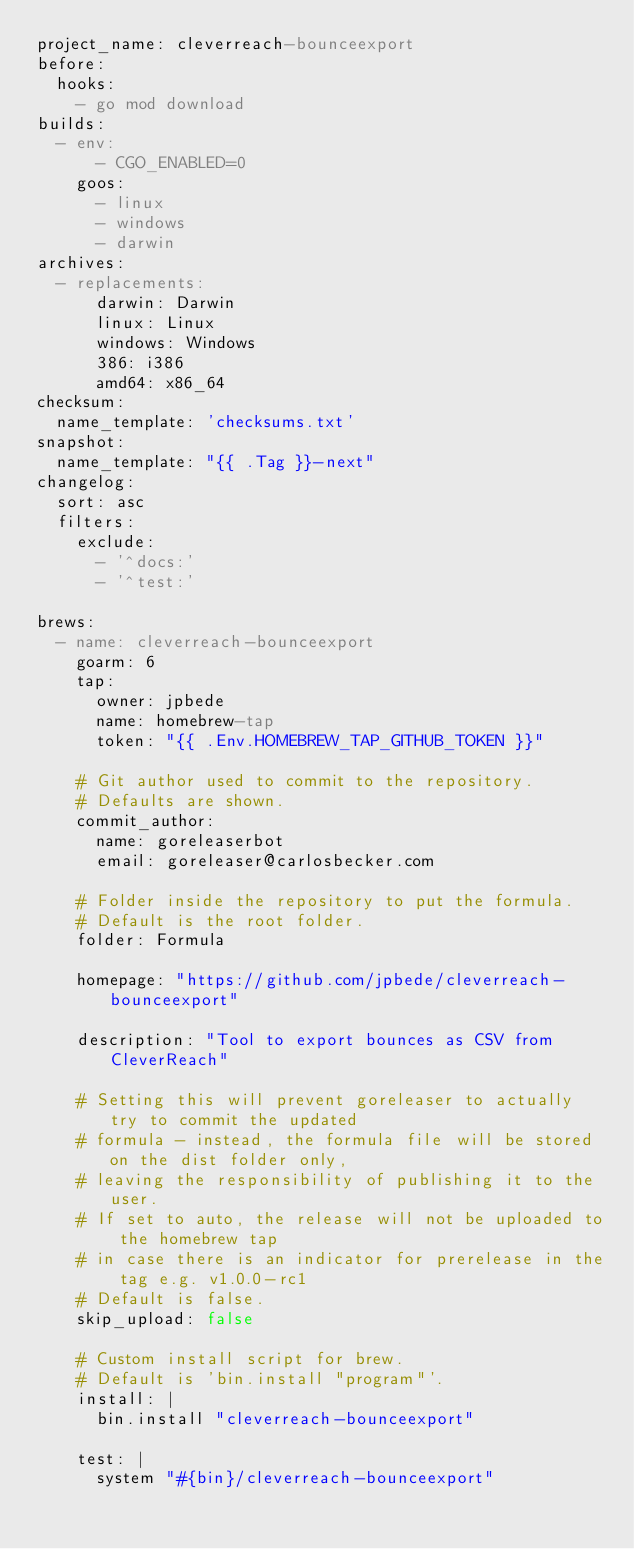Convert code to text. <code><loc_0><loc_0><loc_500><loc_500><_YAML_>project_name: cleverreach-bounceexport
before:
  hooks:
    - go mod download
builds:
  - env:
      - CGO_ENABLED=0
    goos:
      - linux
      - windows
      - darwin
archives:
  - replacements:
      darwin: Darwin
      linux: Linux
      windows: Windows
      386: i386
      amd64: x86_64
checksum:
  name_template: 'checksums.txt'
snapshot:
  name_template: "{{ .Tag }}-next"
changelog:
  sort: asc
  filters:
    exclude:
      - '^docs:'
      - '^test:'

brews:
  - name: cleverreach-bounceexport
    goarm: 6
    tap:
      owner: jpbede
      name: homebrew-tap
      token: "{{ .Env.HOMEBREW_TAP_GITHUB_TOKEN }}"

    # Git author used to commit to the repository.
    # Defaults are shown.
    commit_author:
      name: goreleaserbot
      email: goreleaser@carlosbecker.com

    # Folder inside the repository to put the formula.
    # Default is the root folder.
    folder: Formula

    homepage: "https://github.com/jpbede/cleverreach-bounceexport"

    description: "Tool to export bounces as CSV from CleverReach"

    # Setting this will prevent goreleaser to actually try to commit the updated
    # formula - instead, the formula file will be stored on the dist folder only,
    # leaving the responsibility of publishing it to the user.
    # If set to auto, the release will not be uploaded to the homebrew tap
    # in case there is an indicator for prerelease in the tag e.g. v1.0.0-rc1
    # Default is false.
    skip_upload: false

    # Custom install script for brew.
    # Default is 'bin.install "program"'.
    install: |
      bin.install "cleverreach-bounceexport"

    test: |
      system "#{bin}/cleverreach-bounceexport"
</code> 